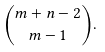<formula> <loc_0><loc_0><loc_500><loc_500>\binom { m + n - 2 } { m - 1 } .</formula> 